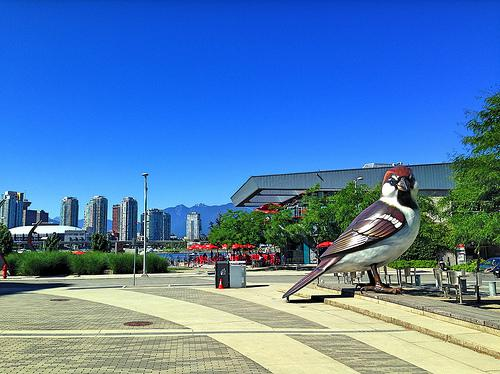Question: who is this walkway for?
Choices:
A. Civilians.
B. Bikes.
C. Pedestrians.
D. Animals.
Answer with the letter. Answer: A Question: when was this taken?
Choices:
A. Nightime.
B. Morning.
C. Dawn.
D. Daytime.
Answer with the letter. Answer: D 